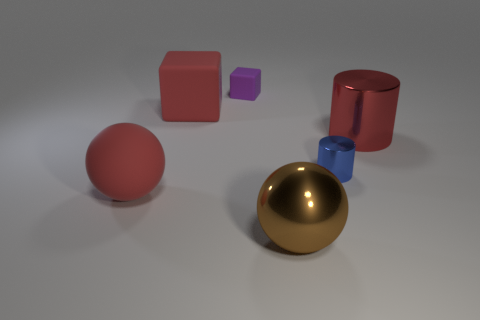Add 4 tiny metal cylinders. How many objects exist? 10 Add 3 tiny shiny cylinders. How many tiny shiny cylinders exist? 4 Subtract 0 gray cubes. How many objects are left? 6 Subtract all cylinders. How many objects are left? 4 Subtract all gray cubes. Subtract all blue cylinders. How many cubes are left? 2 Subtract all brown metal things. Subtract all small matte cubes. How many objects are left? 4 Add 5 large shiny objects. How many large shiny objects are left? 7 